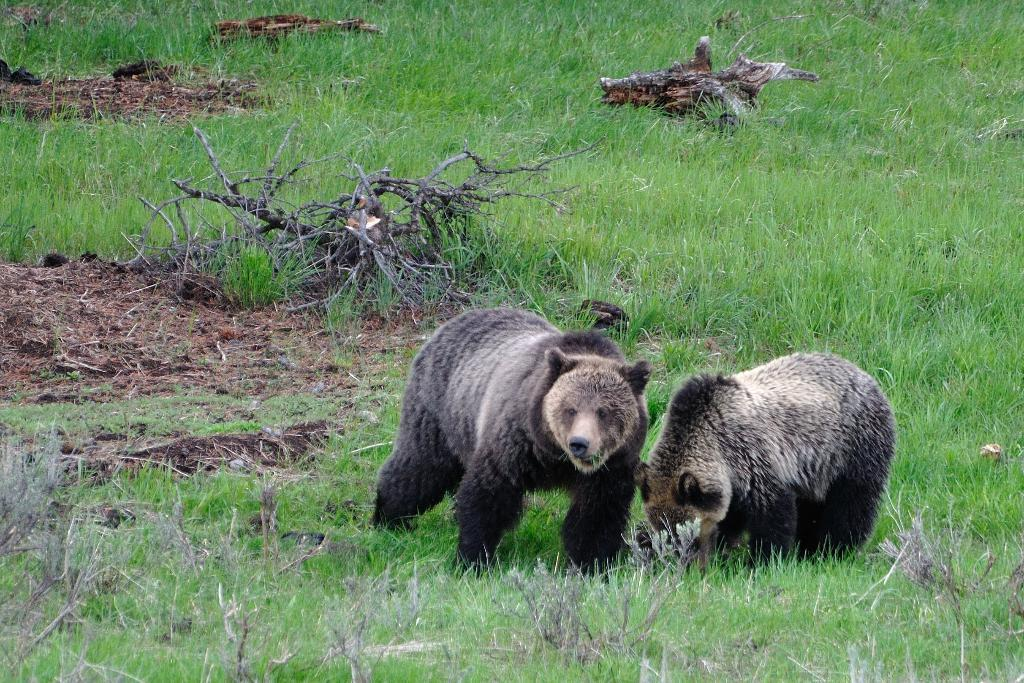What type of natural environment is depicted in the image? The image contains a view of the forest. How many bears can be seen in the image? There are two bears in the image, one black and one brown. What type of vegetation is visible in the image? There is grass visible in the image. What other features of the forest can be seen in the image? There are tree trunks in the image. What type of stamp can be seen on the tree trunk in the image? There is no stamp present on the tree trunk in the image. What material is the brown bear made of in the image? The bears in the image are not made of any material; they are real animals. 